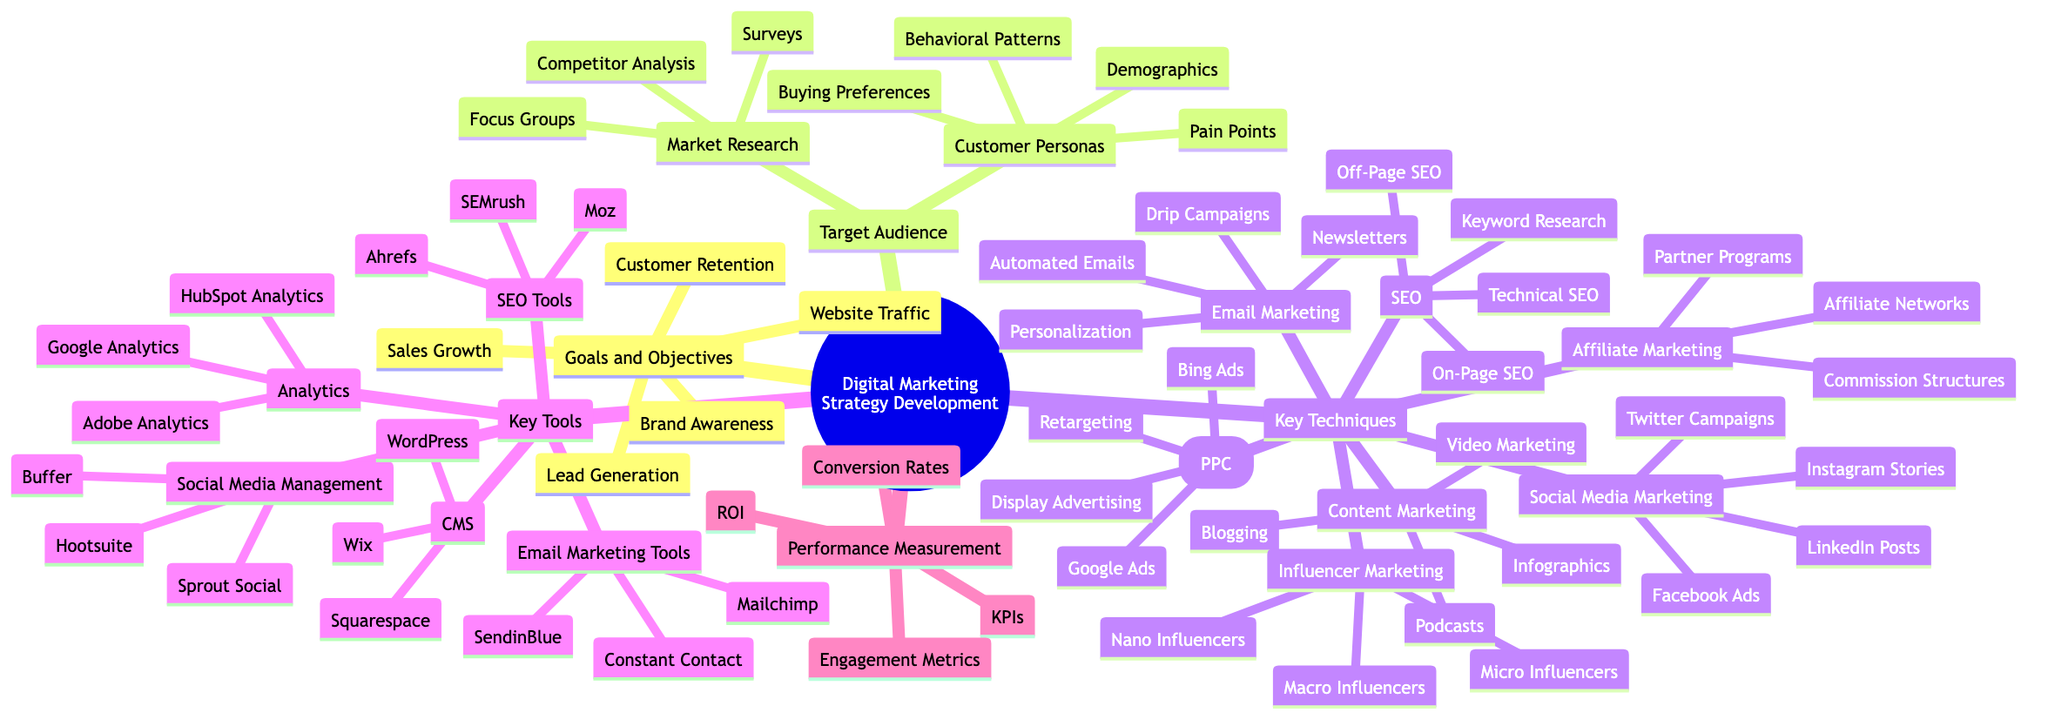What are the primary goals of a digital marketing strategy? The diagram lists several primary goals under the "Goals and Objectives" node, which include Brand Awareness, Lead Generation, Customer Retention, Sales Growth, and Website Traffic. These are the main focus areas for developing a digital marketing strategy.
Answer: Brand Awareness, Lead Generation, Customer Retention, Sales Growth, Website Traffic How many key techniques are identified in the diagram? The "Key Techniques" node reveals seven different techniques: Content Marketing, SEO, Social Media Marketing, Email Marketing, Pay-Per-Click (PPC), Affiliate Marketing, and Influencer Marketing. By counting these branches, we ascertain the total number of key techniques.
Answer: 7 What is one method of market research listed in the diagram? Under the "Market Research" subtree, several methods are provided, including Surveys, Focus Groups, and Competitor Analysis. Any of these methods can be accepted as an answer to the question.
Answer: Surveys (or Focus Groups or Competitor Analysis) Which tools are used for SEO according to the diagram? The "SEO Tools" node provides three specific tools: SEMrush, Ahrefs, and Moz. The question asks for tools related specifically to SEO, which leads directly to this node's content.
Answer: SEMrush, Ahrefs, Moz Which type of influencers is associated with influencer marketing according to the mind map? The "Influencer Marketing" category includes three types: Nano Influencers, Micro Influencers, and Macro Influencers. This node specifically outlines the types of influencers that can be part of an influencer marketing strategy.
Answer: Nano Influencers, Micro Influencers, Macro Influencers What does the "Performance Measurement" category focus on? The diagram indicates that "Performance Measurement" includes KPIs, ROI, Conversion Rates, and Engagement Metrics. This section details the key metrics for assessing the effectiveness of a digital marketing strategy.
Answer: KPIs, ROI, Conversion Rates, Engagement Metrics How will customer personas be shaped according to the diagram? The "Customer Personas" node shows four aspects that shape personas: Demographics, Behavioral Patterns, Pain Points, and Buying Preferences. Each of these aspects is crucial for understanding and creating effective customer personas.
Answer: Demographics, Behavioral Patterns, Pain Points, Buying Preferences What is one tool used for analytics outlined in the diagram? The "Analytics" subtree lists three specific tools, including Google Analytics, Adobe Analytics, and HubSpot Analytics. Any one of these can be used as the answer.
Answer: Google Analytics (or Adobe Analytics or HubSpot Analytics) 